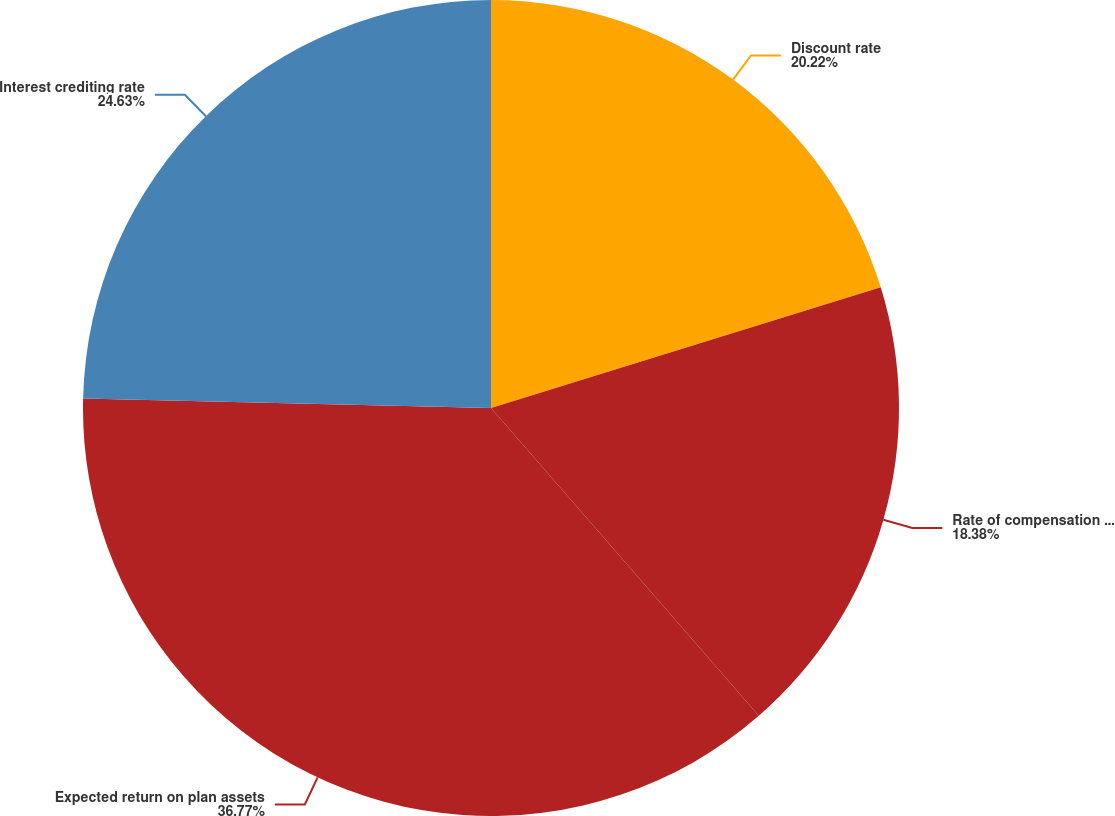<chart> <loc_0><loc_0><loc_500><loc_500><pie_chart><fcel>Discount rate<fcel>Rate of compensation increase<fcel>Expected return on plan assets<fcel>Interest crediting rate<nl><fcel>20.22%<fcel>18.38%<fcel>36.76%<fcel>24.63%<nl></chart> 